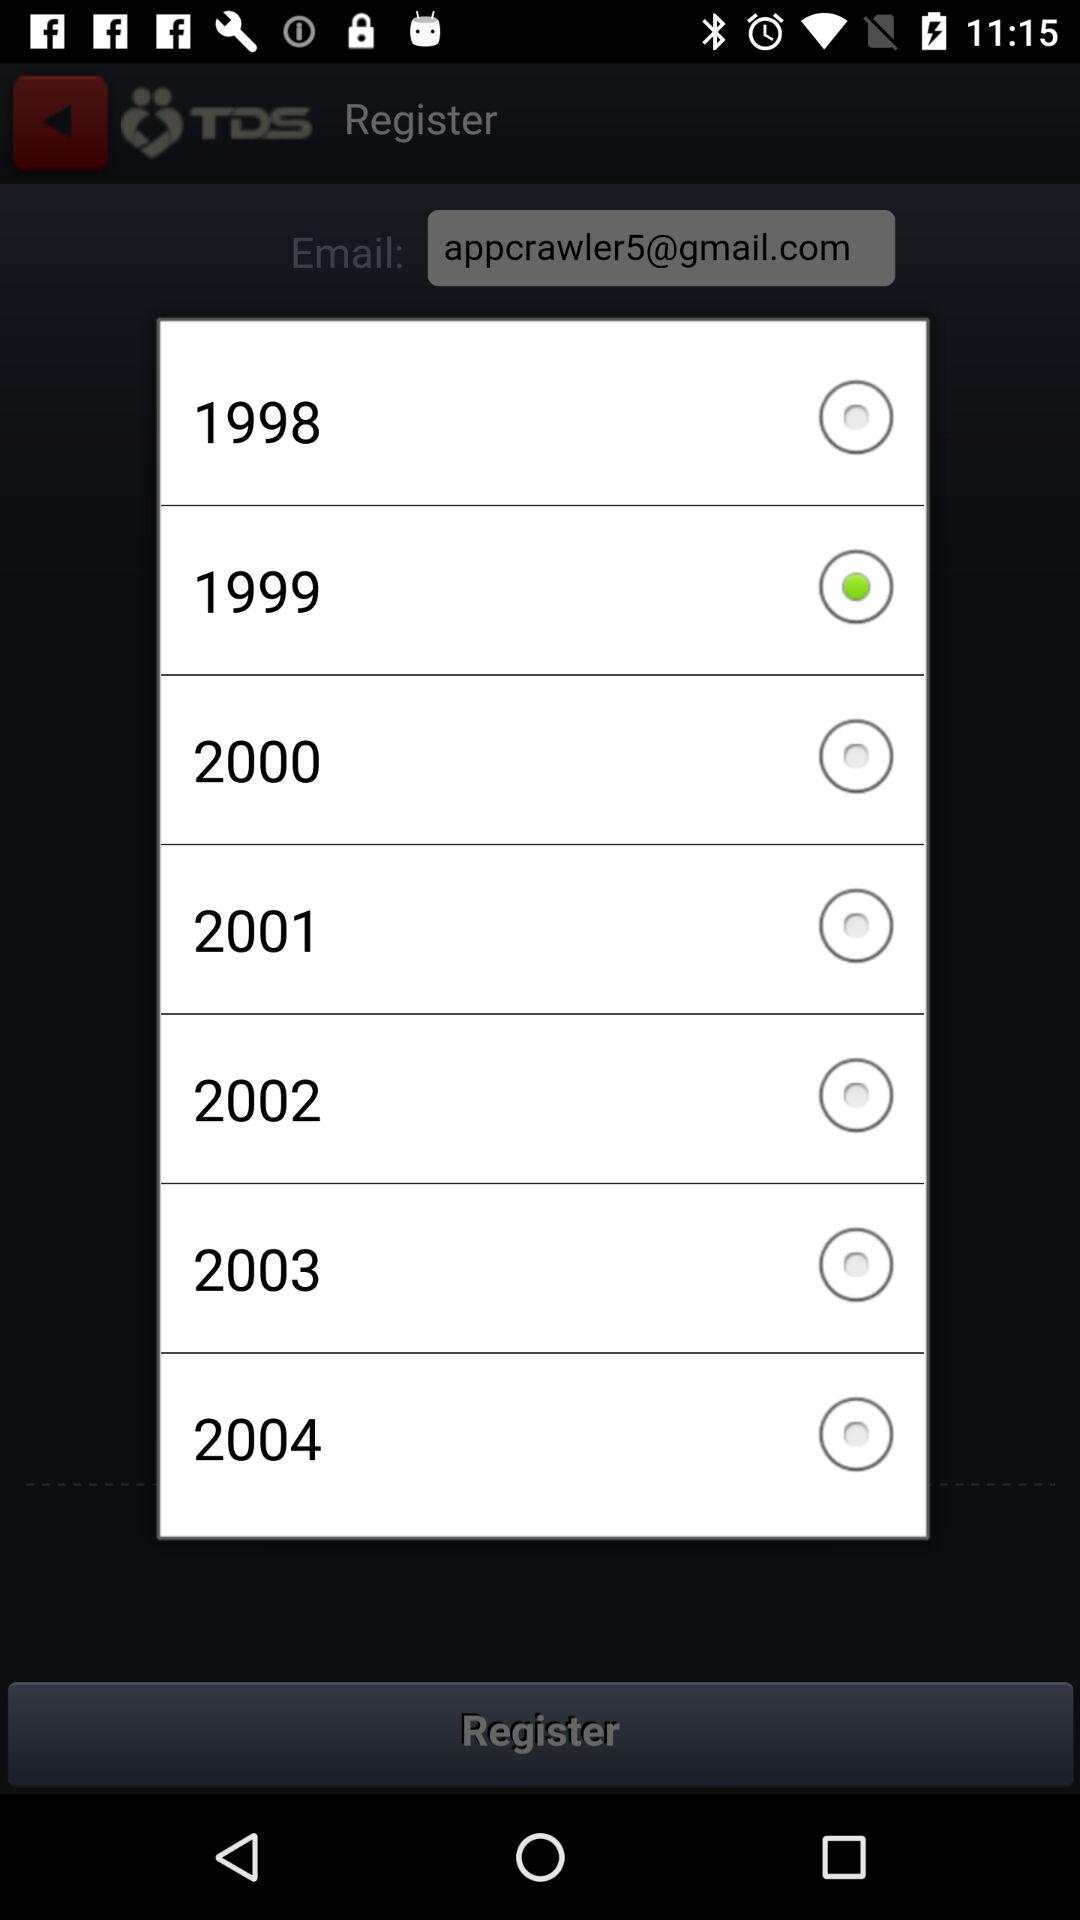Which year is selected? The selected year is 1999. 